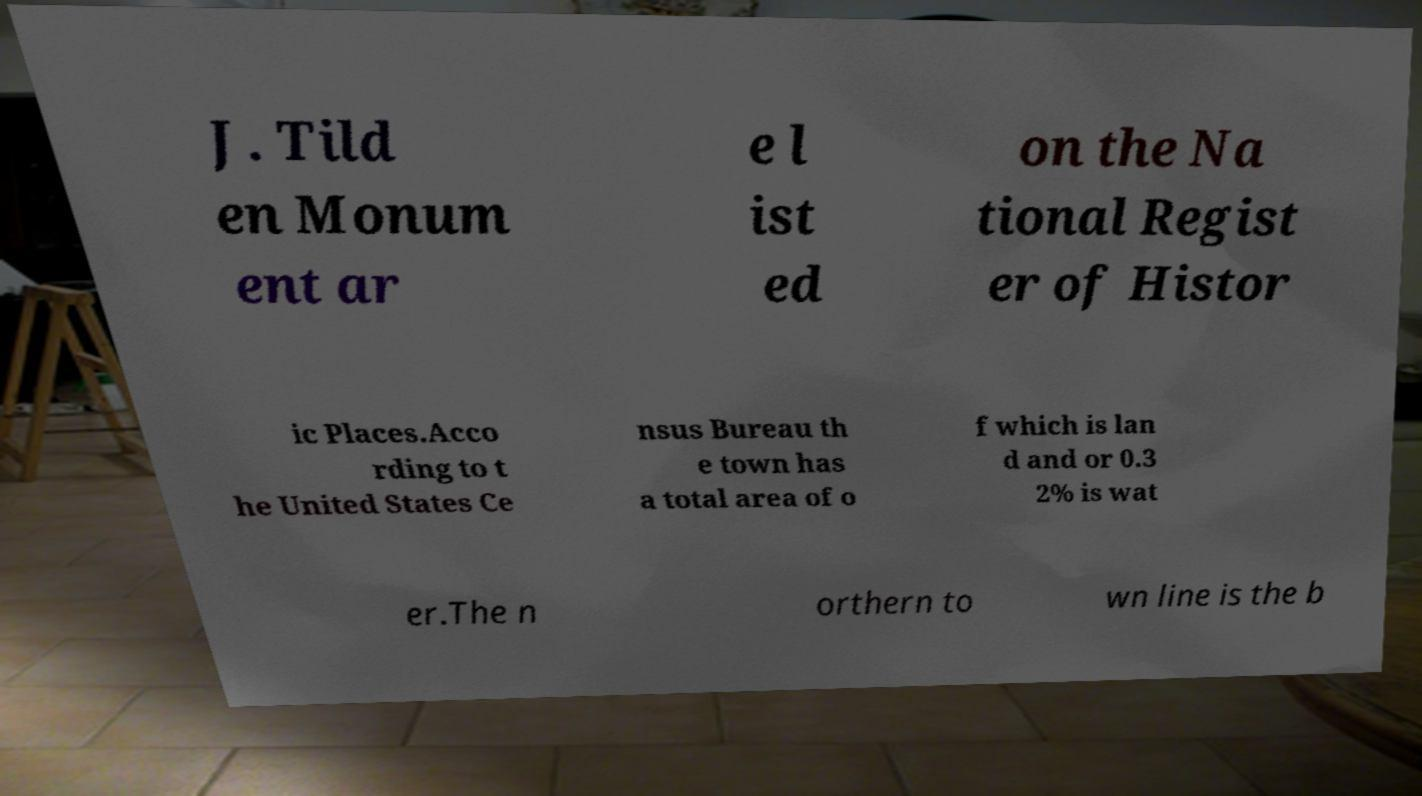Can you accurately transcribe the text from the provided image for me? J. Tild en Monum ent ar e l ist ed on the Na tional Regist er of Histor ic Places.Acco rding to t he United States Ce nsus Bureau th e town has a total area of o f which is lan d and or 0.3 2% is wat er.The n orthern to wn line is the b 